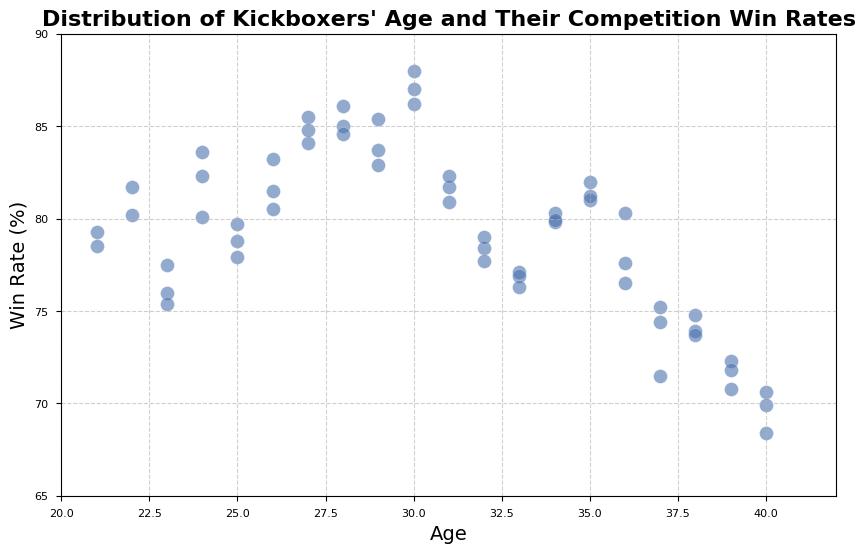what is the range of ages of kickboxers in the plot? The plot shows the ages of kickboxers ranging from 21 to 40 years old.
Answer: 21 to 40 years old Which age group has the highest win rate? By observing the plot, the kickboxers aged 30 have the highest dots, indicating the highest win rates.
Answer: 30 years old How does the win rate trend change with age based on the scatter plot? The scatter plot generally shows that win rates increase from age 21, peak around 30, and then gradually decrease as age increases.
Answer: Increases until 30, then decreases What is the approximate win rate of a 35-year-old kickboxer? To find the win rate for 35-year-olds, look at the scatter plot around the age 35 on the x-axis. The corresponding y-values, which represent win rates, are approximately between 80-82%.
Answer: Approximately 80-82% Compare the win rates of kickboxers aged 23 and 38. Locate the data points for ages 23 and 38 on the plot. The win rates at age 23 are between 75-77.5%, while those at age 38 are between 73.7-74.8%.
Answer: 75-77.5% at age 23, 73.7-74.8% at age 38 What is the variation range of win rates for kickboxers aged 28? Check the scatter plot at age 28 and observe the y-values. The win rates for 28-year-olds range approximately from 84.6% to 86.1%.
Answer: 84.6% to 86.1% Is there any age group with all kickboxers having win rates below 80%? By examining the scatter plot, none of the age groups have all their win rates below 80%, even though some individual data points are below 80%.
Answer: No What age has the most consistent win rates? Check the spread of data points for each age group. The ages with the least spread (or clustering closely) indicate consistency. Ages like 21 and 40 have closely clustered points.
Answer: 21 and 40 years old How does the win rate distribution of 30-year-old kickboxers compare to 40-year-old kickboxers? Locate the points for ages 30 and 40. For age 30, the win rates are around 86-88%. For age 40, it's around 68-70%. This illustrates that 30-year-olds have higher and less variable win rates.
Answer: Higher and less variable at age 30 If you average the win rates of 29-year-old kickboxers, what approximate value do you get? Look at the win rates for age 29: 83.7%, 82.9%, and 85.4%. Adding them and dividing by 3 gives (83.7 + 82.9 + 85.4) / 3 = ~84%.
Answer: Approximately 84% 